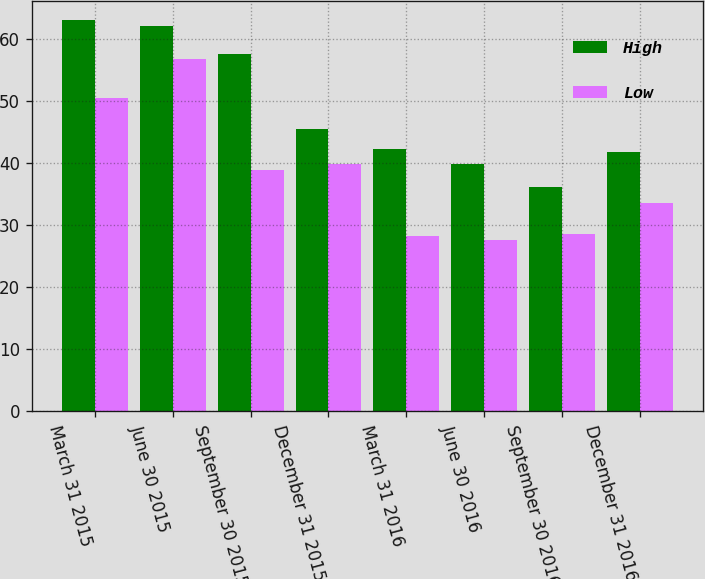Convert chart to OTSL. <chart><loc_0><loc_0><loc_500><loc_500><stacked_bar_chart><ecel><fcel>March 31 2015<fcel>June 30 2015<fcel>September 30 2015<fcel>December 31 2015<fcel>March 31 2016<fcel>June 30 2016<fcel>September 30 2016<fcel>December 31 2016<nl><fcel>High<fcel>63.01<fcel>62.08<fcel>57.65<fcel>45.53<fcel>42.25<fcel>39.93<fcel>36.12<fcel>41.86<nl><fcel>Low<fcel>50.46<fcel>56.84<fcel>38.89<fcel>39.82<fcel>28.23<fcel>27.69<fcel>28.52<fcel>33.64<nl></chart> 